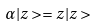Convert formula to latex. <formula><loc_0><loc_0><loc_500><loc_500>\alpha | z > = z | z ></formula> 